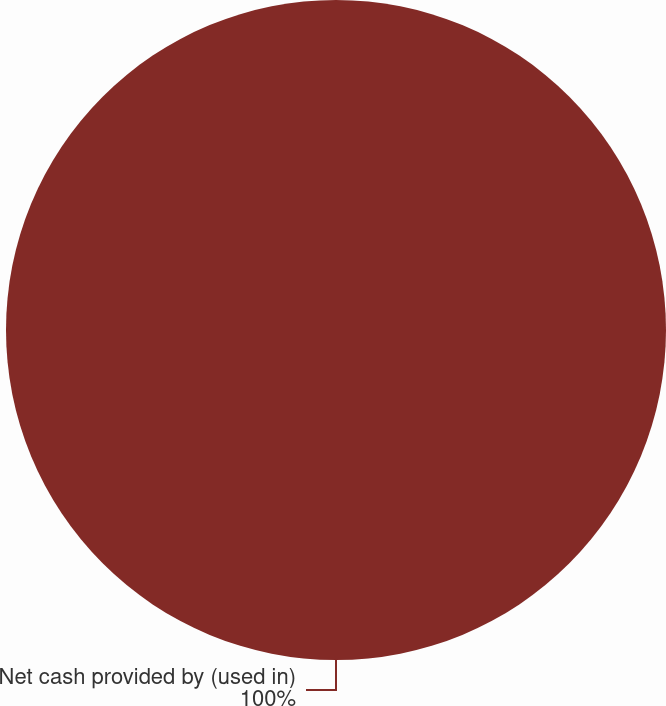Convert chart. <chart><loc_0><loc_0><loc_500><loc_500><pie_chart><fcel>Net cash provided by (used in)<nl><fcel>100.0%<nl></chart> 